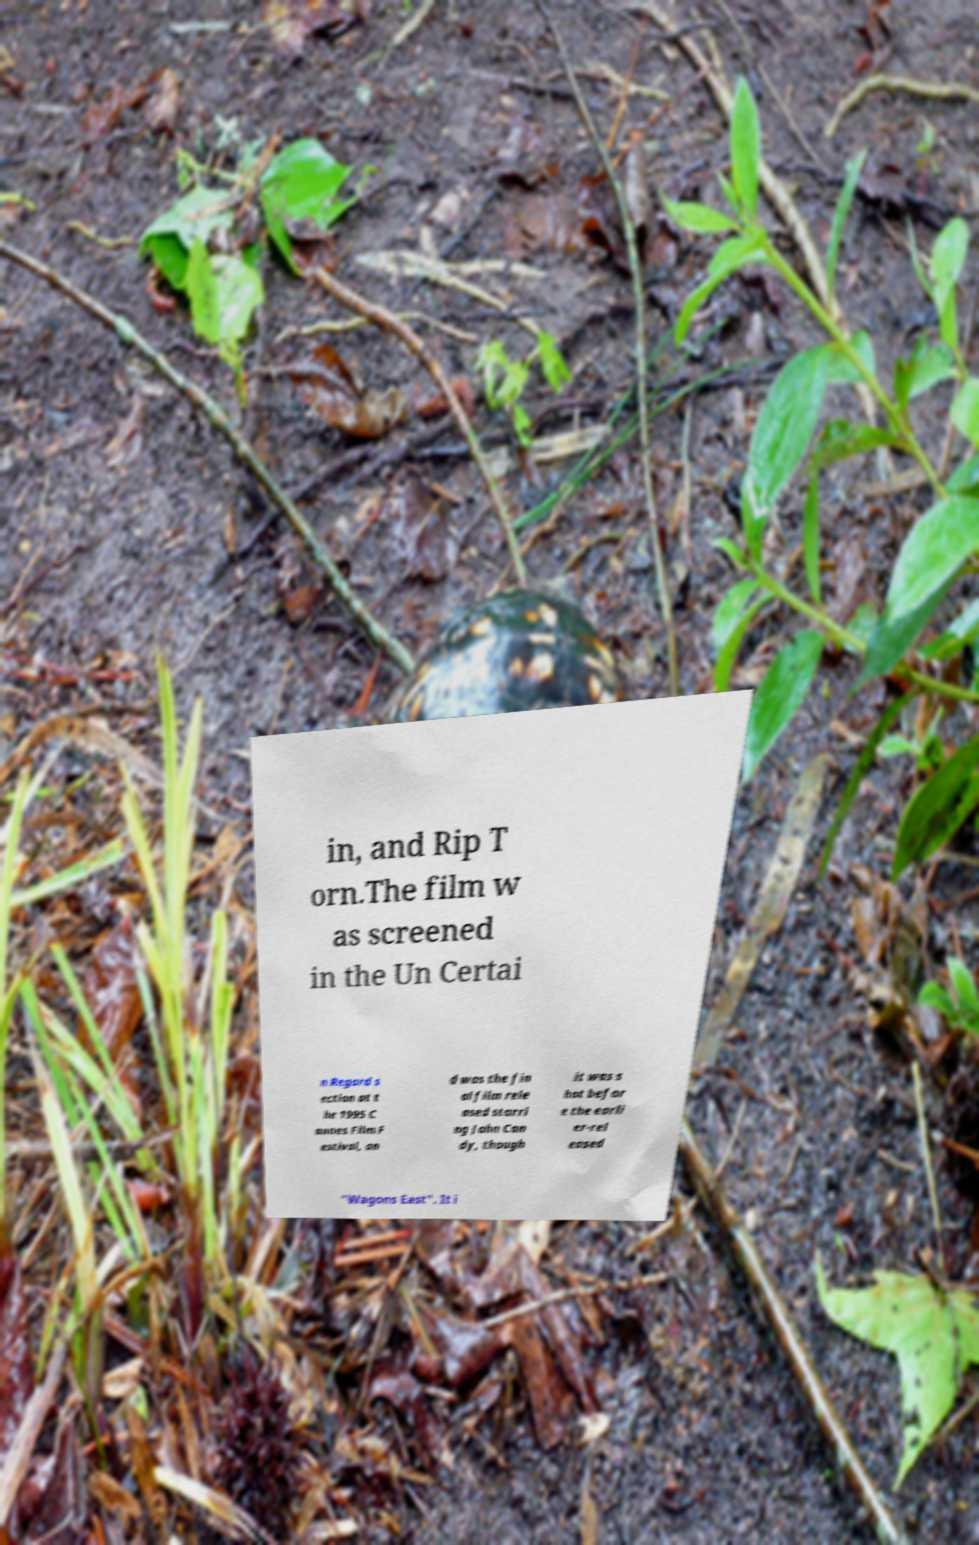I need the written content from this picture converted into text. Can you do that? in, and Rip T orn.The film w as screened in the Un Certai n Regard s ection at t he 1995 C annes Film F estival, an d was the fin al film rele ased starri ng John Can dy, though it was s hot befor e the earli er-rel eased "Wagons East". It i 